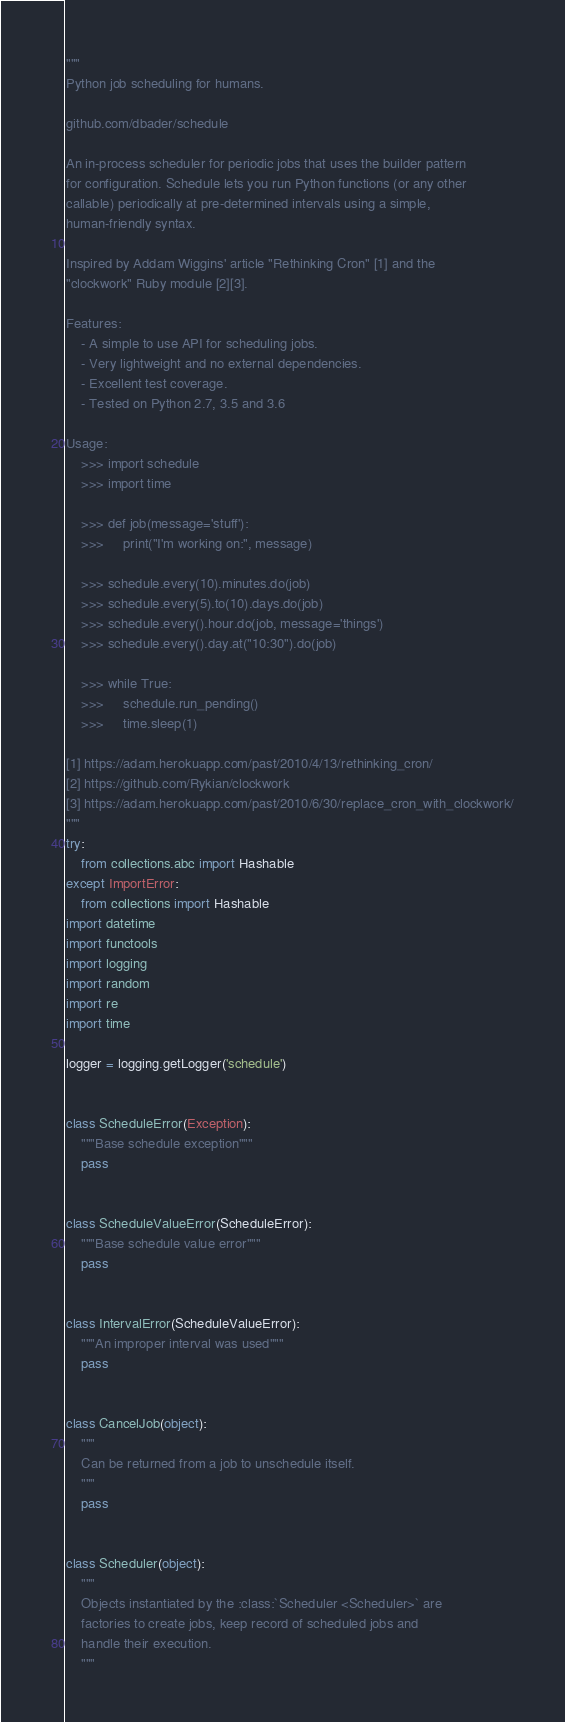<code> <loc_0><loc_0><loc_500><loc_500><_Python_>"""
Python job scheduling for humans.

github.com/dbader/schedule

An in-process scheduler for periodic jobs that uses the builder pattern
for configuration. Schedule lets you run Python functions (or any other
callable) periodically at pre-determined intervals using a simple,
human-friendly syntax.

Inspired by Addam Wiggins' article "Rethinking Cron" [1] and the
"clockwork" Ruby module [2][3].

Features:
    - A simple to use API for scheduling jobs.
    - Very lightweight and no external dependencies.
    - Excellent test coverage.
    - Tested on Python 2.7, 3.5 and 3.6

Usage:
    >>> import schedule
    >>> import time

    >>> def job(message='stuff'):
    >>>     print("I'm working on:", message)

    >>> schedule.every(10).minutes.do(job)
    >>> schedule.every(5).to(10).days.do(job)
    >>> schedule.every().hour.do(job, message='things')
    >>> schedule.every().day.at("10:30").do(job)

    >>> while True:
    >>>     schedule.run_pending()
    >>>     time.sleep(1)

[1] https://adam.herokuapp.com/past/2010/4/13/rethinking_cron/
[2] https://github.com/Rykian/clockwork
[3] https://adam.herokuapp.com/past/2010/6/30/replace_cron_with_clockwork/
"""
try:
    from collections.abc import Hashable
except ImportError:
    from collections import Hashable
import datetime
import functools
import logging
import random
import re
import time

logger = logging.getLogger('schedule')


class ScheduleError(Exception):
    """Base schedule exception"""
    pass


class ScheduleValueError(ScheduleError):
    """Base schedule value error"""
    pass


class IntervalError(ScheduleValueError):
    """An improper interval was used"""
    pass


class CancelJob(object):
    """
    Can be returned from a job to unschedule itself.
    """
    pass


class Scheduler(object):
    """
    Objects instantiated by the :class:`Scheduler <Scheduler>` are
    factories to create jobs, keep record of scheduled jobs and
    handle their execution.
    """</code> 